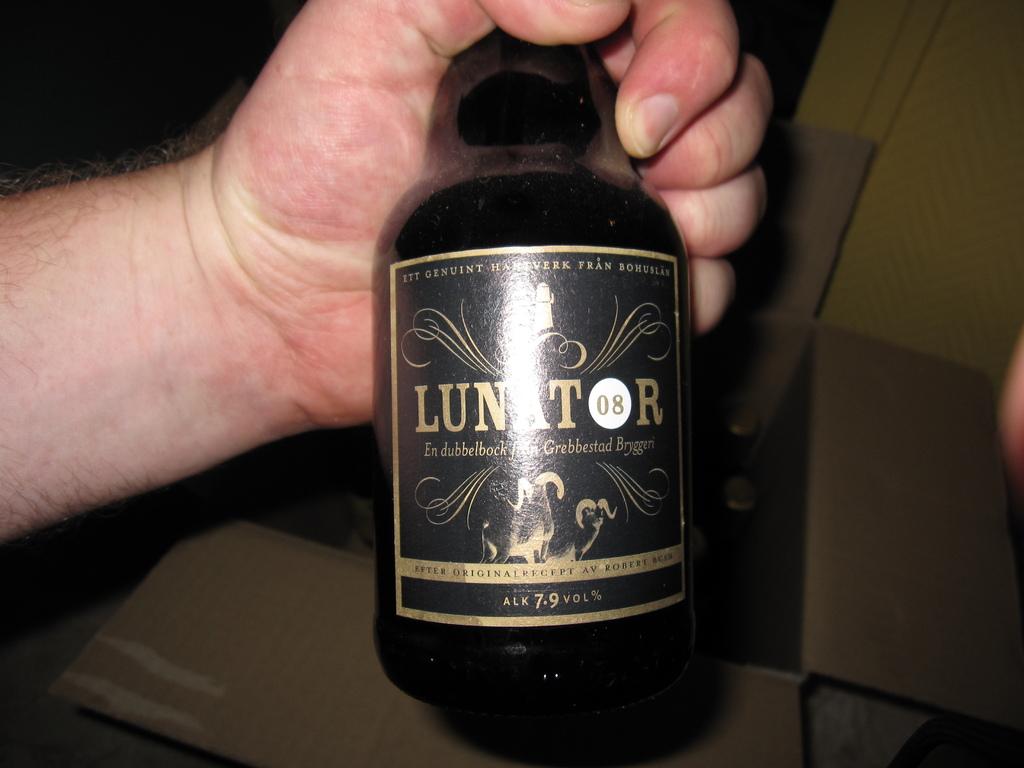What is the two numbers in the white circle?
Your response must be concise. 08. 